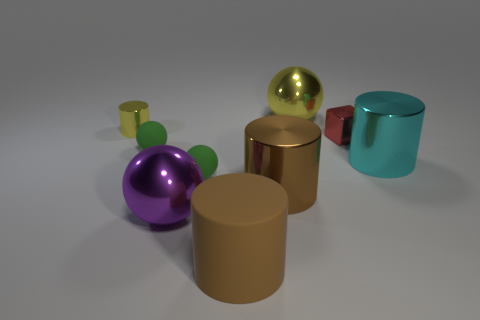Is the size of the purple sphere the same as the block?
Make the answer very short. No. What number of metallic objects are either big purple balls or large yellow spheres?
Give a very brief answer. 2. There is a yellow cylinder that is the same size as the red thing; what is its material?
Your answer should be compact. Metal. How many other things are the same material as the tiny cube?
Offer a very short reply. 5. Is the number of tiny cylinders to the right of the big purple thing less than the number of small red cubes?
Ensure brevity in your answer.  Yes. Do the brown matte thing and the cyan metallic object have the same shape?
Offer a very short reply. Yes. There is a yellow thing left of the large shiny cylinder on the left side of the large sphere right of the purple metallic ball; what is its size?
Provide a succinct answer. Small. There is another large brown thing that is the same shape as the brown matte object; what is its material?
Keep it short and to the point. Metal. Are there any other things that have the same size as the cube?
Your response must be concise. Yes. There is a yellow shiny thing on the left side of the cylinder in front of the large brown shiny thing; what is its size?
Keep it short and to the point. Small. 